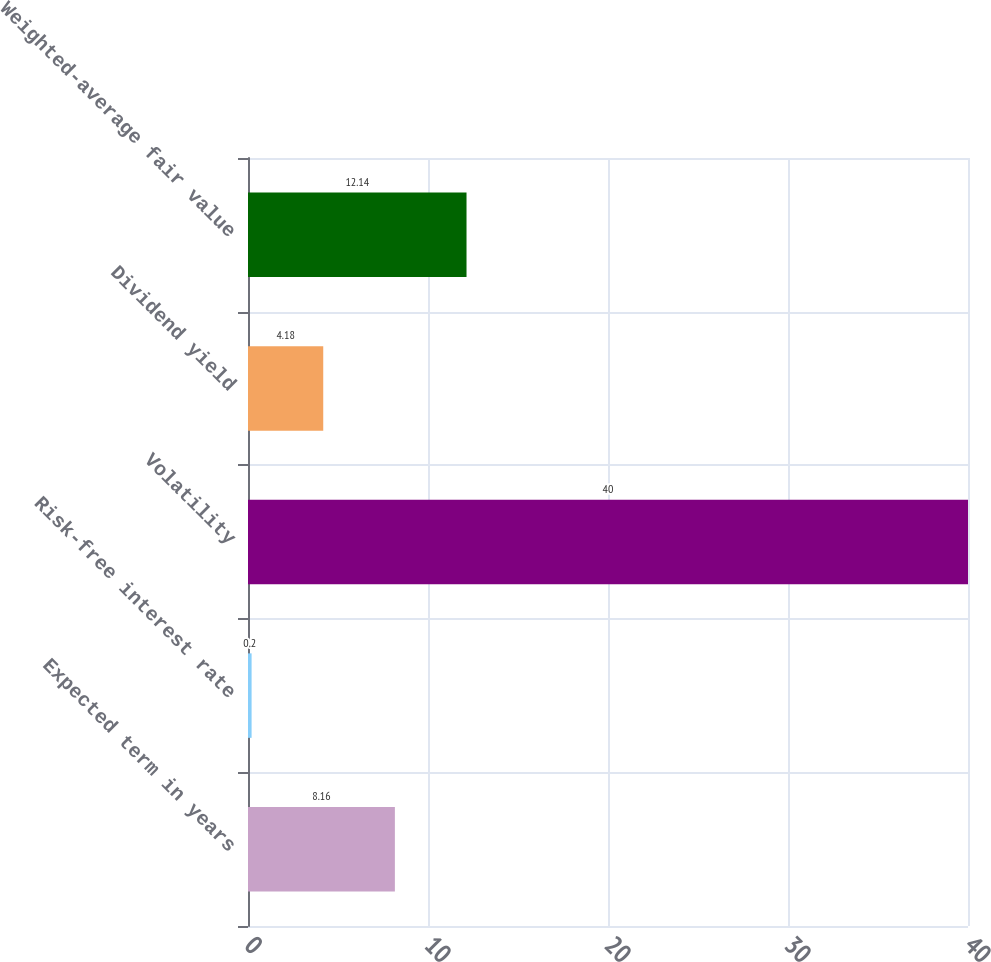Convert chart to OTSL. <chart><loc_0><loc_0><loc_500><loc_500><bar_chart><fcel>Expected term in years<fcel>Risk-free interest rate<fcel>Volatility<fcel>Dividend yield<fcel>Weighted-average fair value<nl><fcel>8.16<fcel>0.2<fcel>40<fcel>4.18<fcel>12.14<nl></chart> 